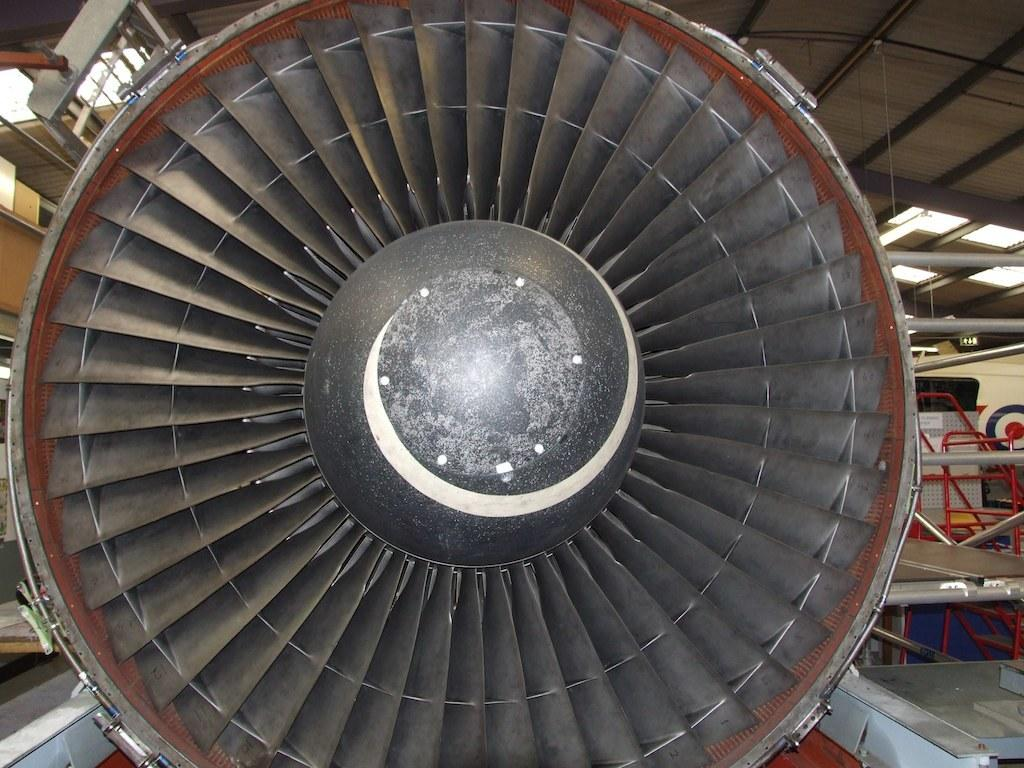What is the main subject of the image? The main subject of the image is an engine. Are there any objects near the engine? Yes, there are objects on both sides of the engine. Where is the engine and the objects located? The engine and objects are inside a shed. How many kittens are playing with the wine inside the jail in the image? There is no jail, wine, or kittens present in the image; it features an engine with objects on both sides inside a shed. 